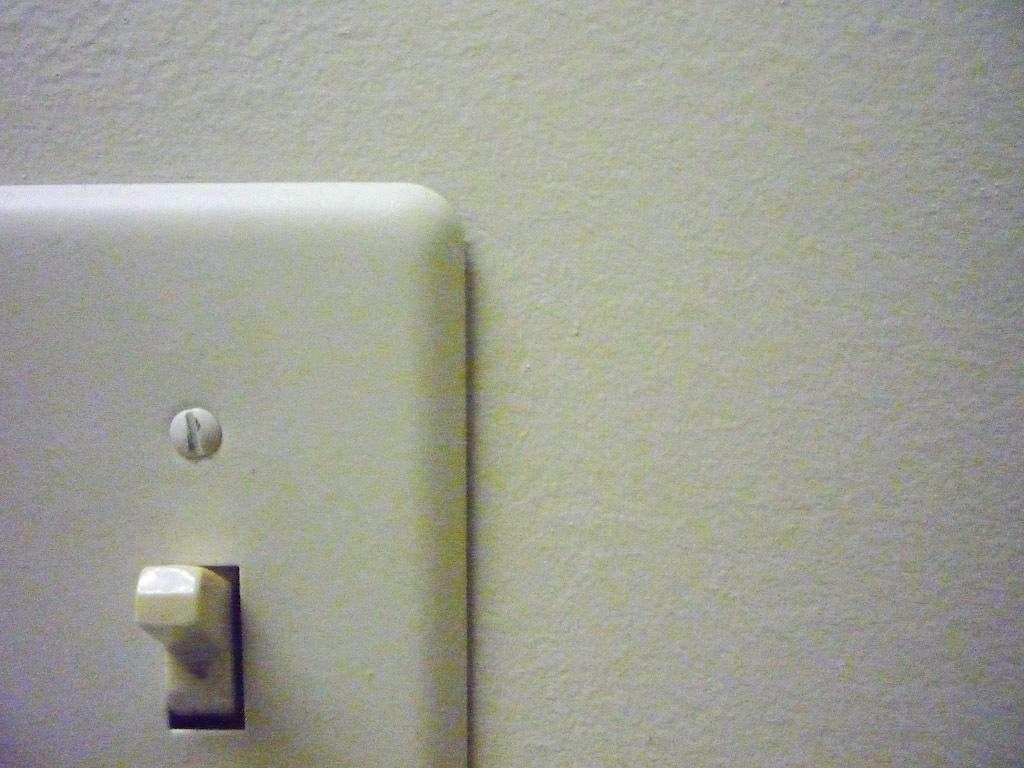What is located on the left side of the image? There is a switch board on the left side of the image. What can be seen in the background of the image? There is a wall in the background of the image. What emotion is displayed by the person in the scene of the image? There is no person present in the image, so it is not possible to determine any emotions or scenes. 